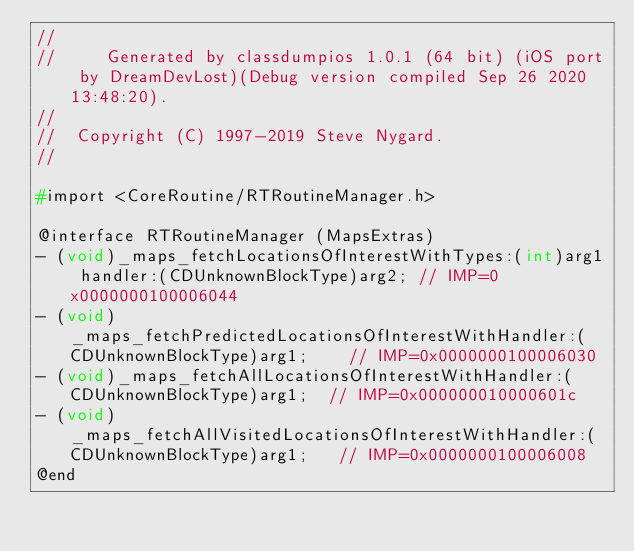<code> <loc_0><loc_0><loc_500><loc_500><_C_>//
//     Generated by classdumpios 1.0.1 (64 bit) (iOS port by DreamDevLost)(Debug version compiled Sep 26 2020 13:48:20).
//
//  Copyright (C) 1997-2019 Steve Nygard.
//

#import <CoreRoutine/RTRoutineManager.h>

@interface RTRoutineManager (MapsExtras)
- (void)_maps_fetchLocationsOfInterestWithTypes:(int)arg1 handler:(CDUnknownBlockType)arg2;	// IMP=0x0000000100006044
- (void)_maps_fetchPredictedLocationsOfInterestWithHandler:(CDUnknownBlockType)arg1;	// IMP=0x0000000100006030
- (void)_maps_fetchAllLocationsOfInterestWithHandler:(CDUnknownBlockType)arg1;	// IMP=0x000000010000601c
- (void)_maps_fetchAllVisitedLocationsOfInterestWithHandler:(CDUnknownBlockType)arg1;	// IMP=0x0000000100006008
@end

</code> 